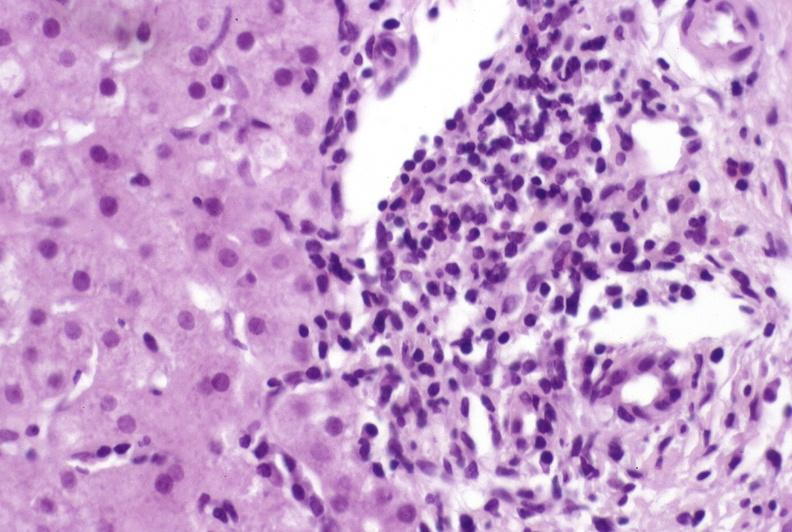what is present?
Answer the question using a single word or phrase. Hepatobiliary 